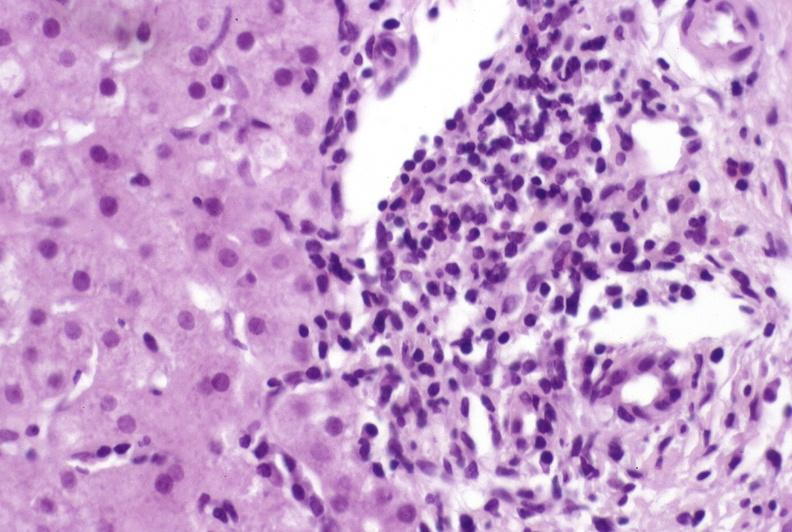what is present?
Answer the question using a single word or phrase. Hepatobiliary 